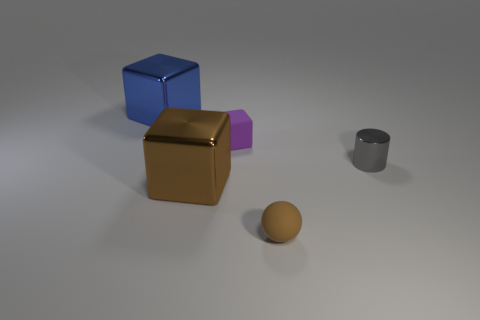Add 2 small rubber objects. How many objects exist? 7 Add 1 big metallic things. How many big metallic things are left? 3 Add 1 blue shiny cylinders. How many blue shiny cylinders exist? 1 Subtract all brown blocks. How many blocks are left? 2 Subtract all metal blocks. How many blocks are left? 1 Subtract 0 red cylinders. How many objects are left? 5 Subtract all spheres. How many objects are left? 4 Subtract 1 spheres. How many spheres are left? 0 Subtract all green cylinders. Subtract all brown spheres. How many cylinders are left? 1 Subtract all cyan cubes. How many red cylinders are left? 0 